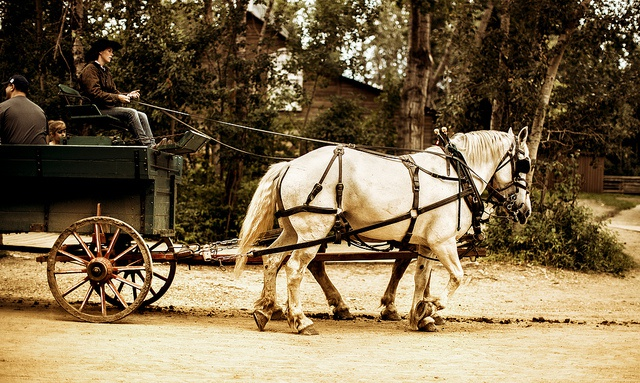Describe the objects in this image and their specific colors. I can see horse in black, ivory, and tan tones, people in black, maroon, and gray tones, people in black, maroon, and gray tones, and people in black, maroon, and brown tones in this image. 